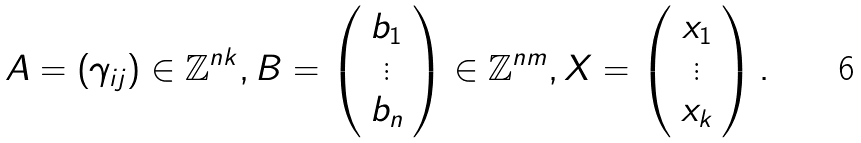Convert formula to latex. <formula><loc_0><loc_0><loc_500><loc_500>A = ( \gamma _ { i j } ) \in \mathbb { Z } ^ { n k } , B = \left ( \begin{array} { c } b _ { 1 } \\ \vdots \\ b _ { n } \end{array} \right ) \in \mathbb { Z } ^ { n m } , X = \left ( \begin{array} { c } x _ { 1 } \\ \vdots \\ x _ { k } \end{array} \right ) .</formula> 